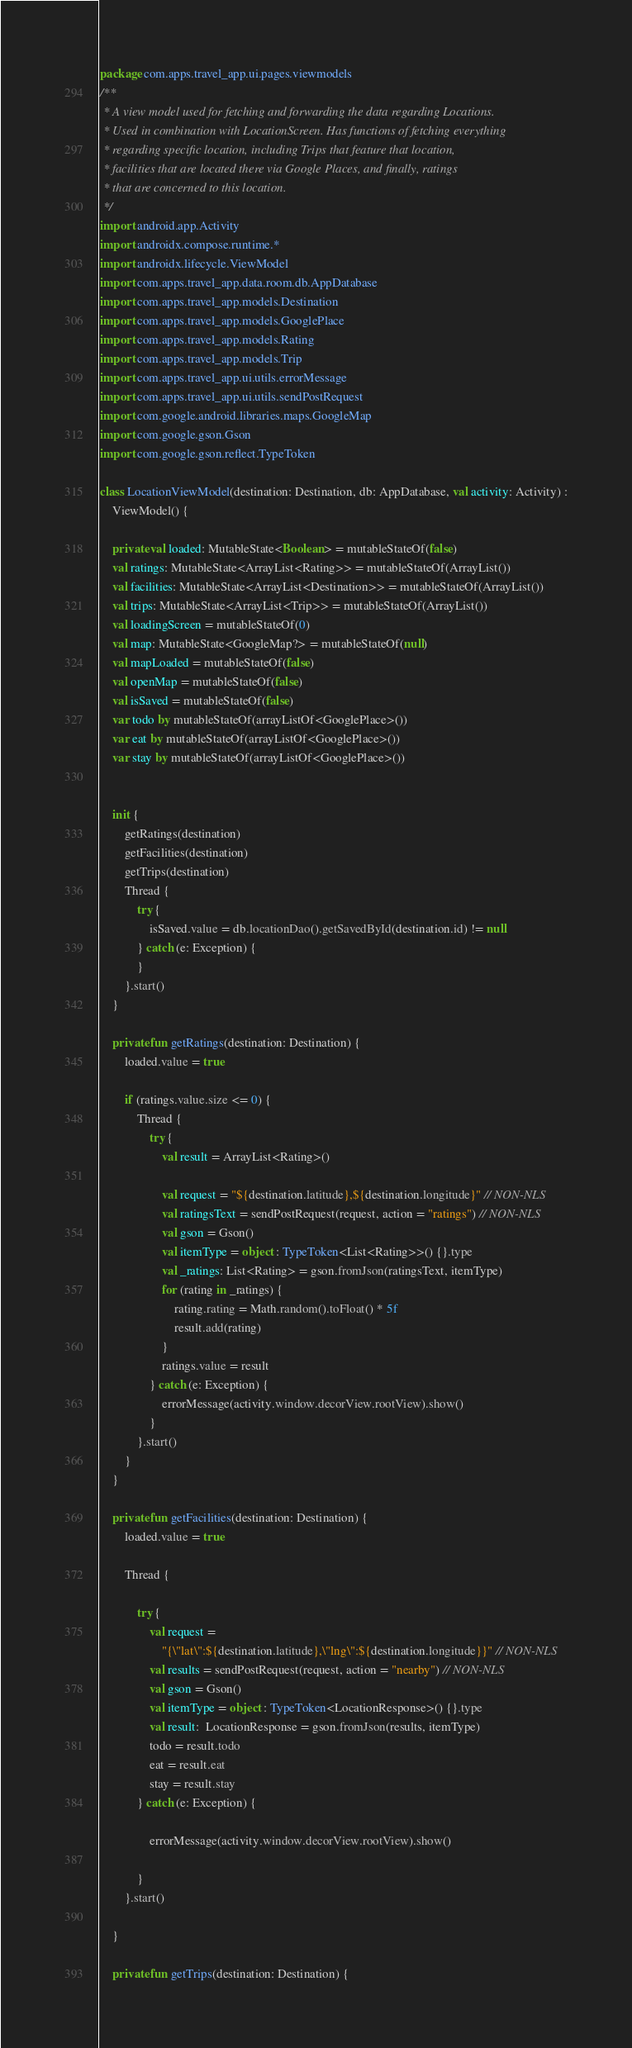<code> <loc_0><loc_0><loc_500><loc_500><_Kotlin_>package com.apps.travel_app.ui.pages.viewmodels
/**
 * A view model used for fetching and forwarding the data regarding Locations.
 * Used in combination with LocationScreen. Has functions of fetching everything
 * regarding specific location, including Trips that feature that location,
 * facilities that are located there via Google Places, and finally, ratings
 * that are concerned to this location.
 */
import android.app.Activity
import androidx.compose.runtime.*
import androidx.lifecycle.ViewModel
import com.apps.travel_app.data.room.db.AppDatabase
import com.apps.travel_app.models.Destination
import com.apps.travel_app.models.GooglePlace
import com.apps.travel_app.models.Rating
import com.apps.travel_app.models.Trip
import com.apps.travel_app.ui.utils.errorMessage
import com.apps.travel_app.ui.utils.sendPostRequest
import com.google.android.libraries.maps.GoogleMap
import com.google.gson.Gson
import com.google.gson.reflect.TypeToken

class LocationViewModel(destination: Destination, db: AppDatabase, val activity: Activity) :
    ViewModel() {

    private val loaded: MutableState<Boolean> = mutableStateOf(false)
    val ratings: MutableState<ArrayList<Rating>> = mutableStateOf(ArrayList())
    val facilities: MutableState<ArrayList<Destination>> = mutableStateOf(ArrayList())
    val trips: MutableState<ArrayList<Trip>> = mutableStateOf(ArrayList())
    val loadingScreen = mutableStateOf(0)
    val map: MutableState<GoogleMap?> = mutableStateOf(null)
    val mapLoaded = mutableStateOf(false)
    val openMap = mutableStateOf(false)
    val isSaved = mutableStateOf(false)
    var todo by mutableStateOf(arrayListOf<GooglePlace>())
    var eat by mutableStateOf(arrayListOf<GooglePlace>())
    var stay by mutableStateOf(arrayListOf<GooglePlace>())


    init {
        getRatings(destination)
        getFacilities(destination)
        getTrips(destination)
        Thread {
            try {
                isSaved.value = db.locationDao().getSavedById(destination.id) != null
            } catch (e: Exception) {
            }
        }.start()
    }

    private fun getRatings(destination: Destination) {
        loaded.value = true

        if (ratings.value.size <= 0) {
            Thread {
                try {
                    val result = ArrayList<Rating>()

                    val request = "${destination.latitude},${destination.longitude}" // NON-NLS
                    val ratingsText = sendPostRequest(request, action = "ratings") // NON-NLS
                    val gson = Gson()
                    val itemType = object : TypeToken<List<Rating>>() {}.type
                    val _ratings: List<Rating> = gson.fromJson(ratingsText, itemType)
                    for (rating in _ratings) {
                        rating.rating = Math.random().toFloat() * 5f
                        result.add(rating)
                    }
                    ratings.value = result
                } catch (e: Exception) {
                    errorMessage(activity.window.decorView.rootView).show()
                }
            }.start()
        }
    }

    private fun getFacilities(destination: Destination) {
        loaded.value = true

        Thread {

            try {
                val request =
                    "{\"lat\":${destination.latitude},\"lng\":${destination.longitude}}" // NON-NLS
                val results = sendPostRequest(request, action = "nearby") // NON-NLS
                val gson = Gson()
                val itemType = object : TypeToken<LocationResponse>() {}.type
                val result:  LocationResponse = gson.fromJson(results, itemType)
                todo = result.todo
                eat = result.eat
                stay = result.stay
            } catch (e: Exception) {

                errorMessage(activity.window.decorView.rootView).show()

            }
        }.start()

    }

    private fun getTrips(destination: Destination) {</code> 